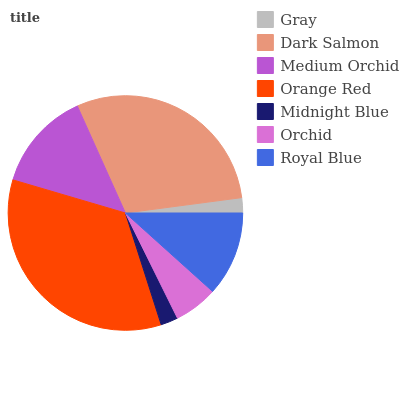Is Gray the minimum?
Answer yes or no. Yes. Is Orange Red the maximum?
Answer yes or no. Yes. Is Dark Salmon the minimum?
Answer yes or no. No. Is Dark Salmon the maximum?
Answer yes or no. No. Is Dark Salmon greater than Gray?
Answer yes or no. Yes. Is Gray less than Dark Salmon?
Answer yes or no. Yes. Is Gray greater than Dark Salmon?
Answer yes or no. No. Is Dark Salmon less than Gray?
Answer yes or no. No. Is Royal Blue the high median?
Answer yes or no. Yes. Is Royal Blue the low median?
Answer yes or no. Yes. Is Orchid the high median?
Answer yes or no. No. Is Orchid the low median?
Answer yes or no. No. 